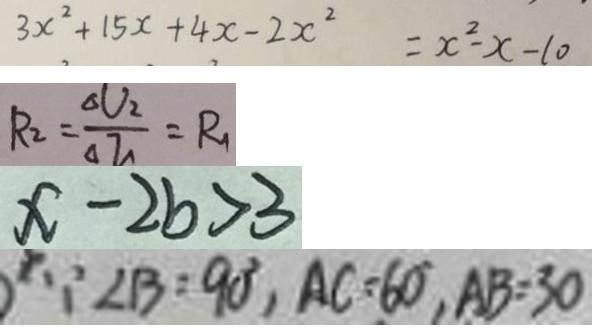Convert formula to latex. <formula><loc_0><loc_0><loc_500><loc_500>3 x ^ { 2 } + 1 5 x + 4 x - 2 x ^ { 2 } = x ^ { 2 } - x - 1 0 
 R _ { 2 } = \frac { \Delta V _ { 2 } } { \Delta I _ { 1 } } = R _ { 1 } 
 x - 2 b > 3 
 \because \angle B = 9 0 ^ { \circ } , A C = 6 0 , A B = 3 0</formula> 